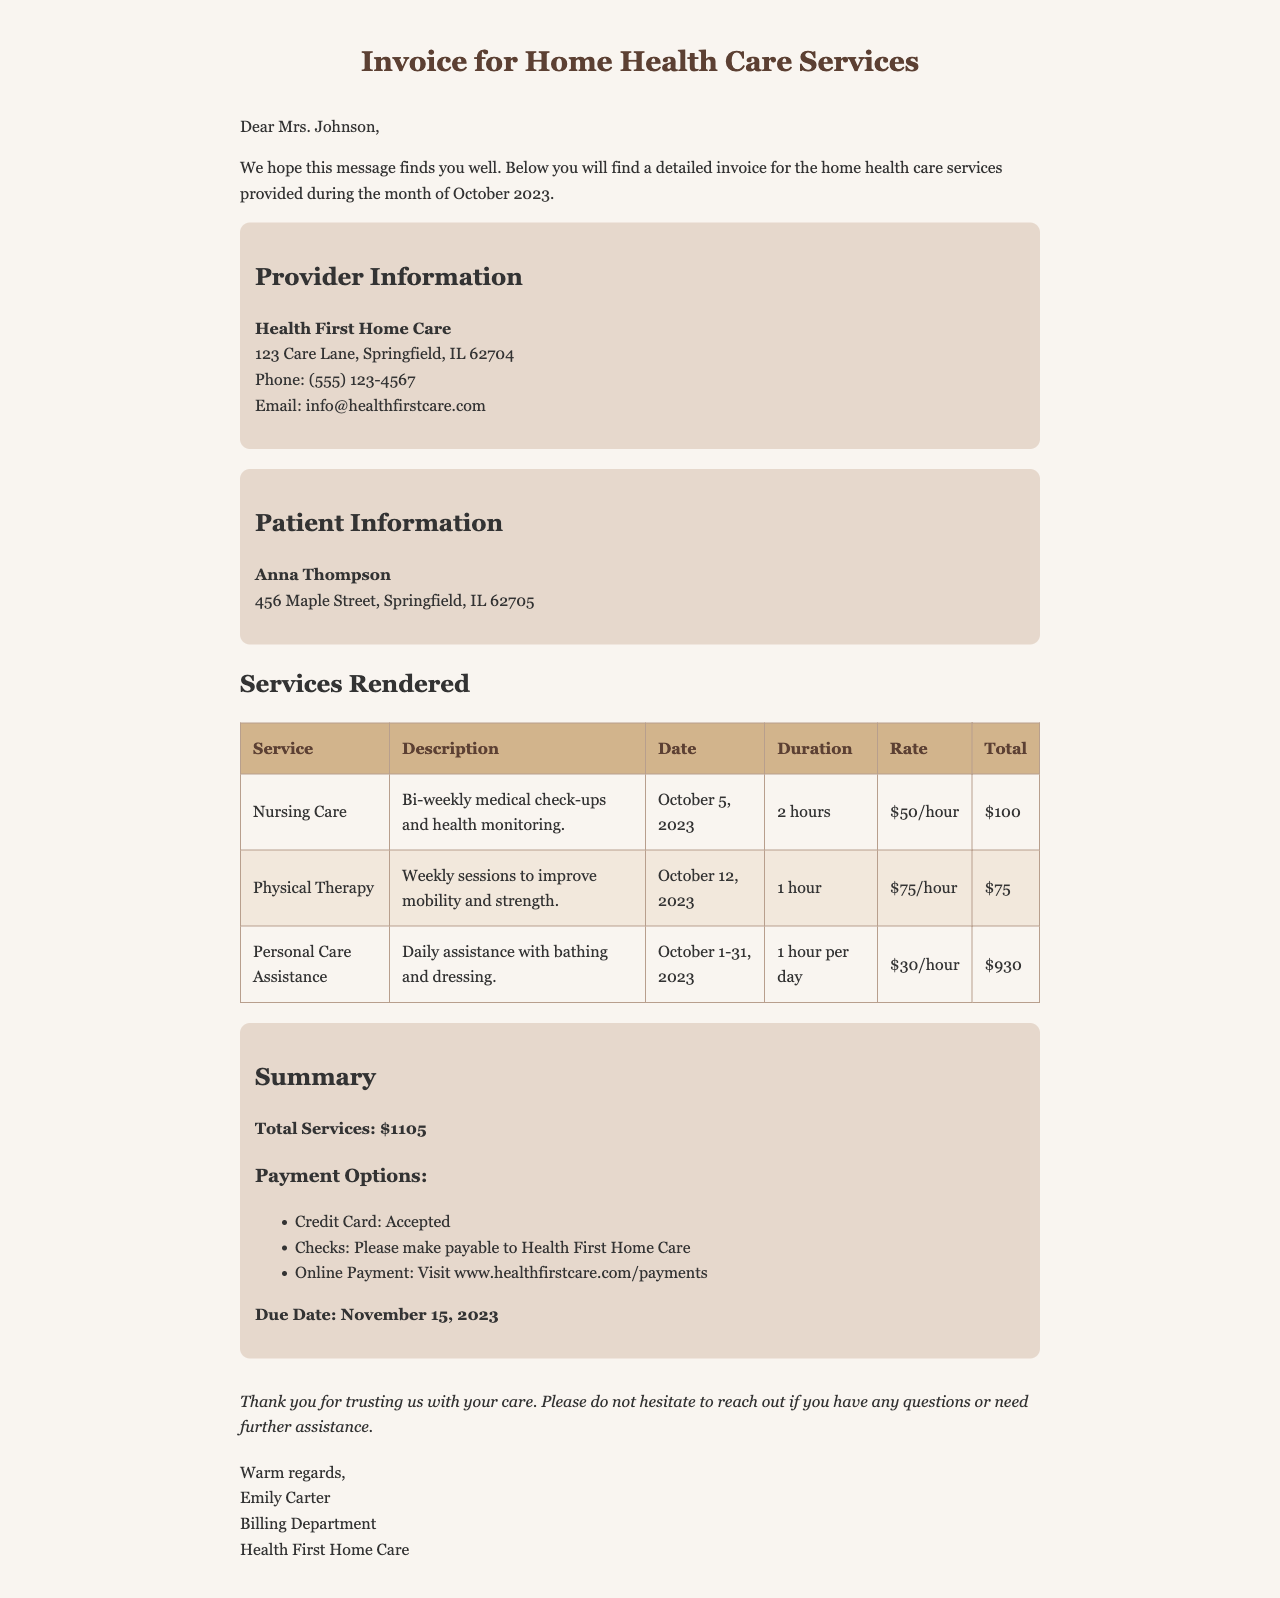What is the total amount due? The total amount due is stated in the summary section as $1105.
Answer: $1105 Who is the patient? The patient’s name is mentioned in the patient information section as Anna Thompson.
Answer: Anna Thompson When is the due date for payment? The due date is specified in the summary section as November 15, 2023.
Answer: November 15, 2023 How many hours of Personal Care Assistance were provided? The document states that there were 1 hour of assistance provided each day for the month of October, totaling 31 hours.
Answer: 31 hours What is the rate for Nursing Care? The rate for Nursing Care is given as $50 per hour in the services rendered table.
Answer: $50/hour What payment options are available? The payment options listed include Credit Card, Checks, and Online Payment.
Answer: Credit Card, Checks, Online Payment What type of service was provided on October 12, 2023? The specific service date noted is Physical Therapy according to the services rendered table.
Answer: Physical Therapy Who is the sender of the invoice? The sender of the invoice is identified at the end of the email as Emily Carter.
Answer: Emily Carter What is the description of the Physical Therapy service? The description states it is for weekly sessions to improve mobility and strength.
Answer: Weekly sessions to improve mobility and strength 